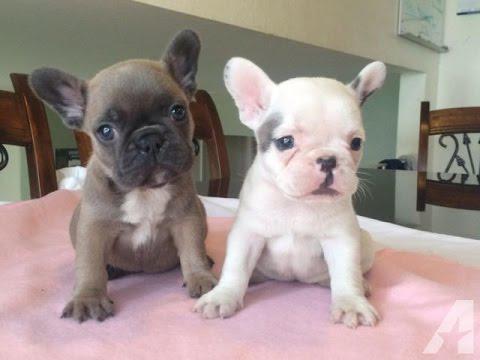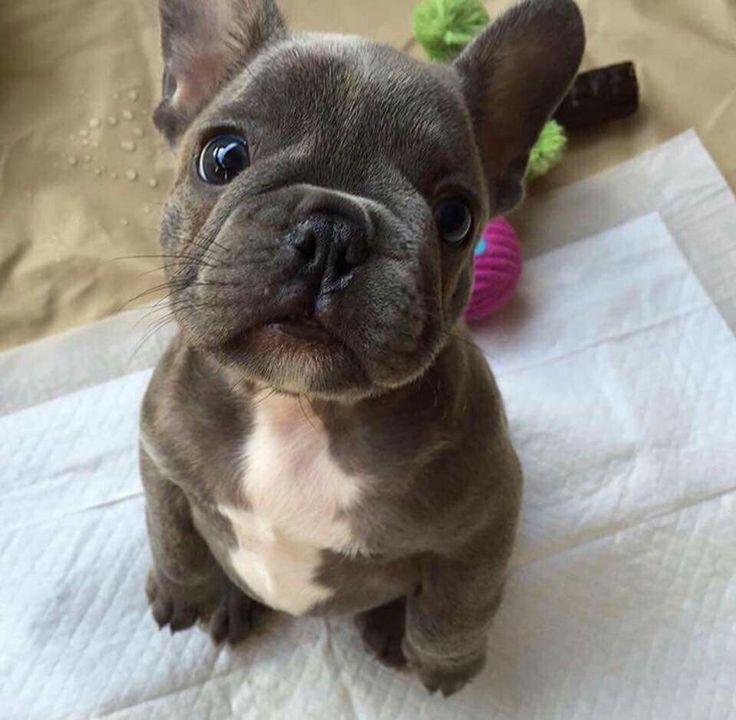The first image is the image on the left, the second image is the image on the right. Considering the images on both sides, is "There are three dogs" valid? Answer yes or no. Yes. The first image is the image on the left, the second image is the image on the right. Given the left and right images, does the statement "There are exactly three puppies." hold true? Answer yes or no. Yes. 